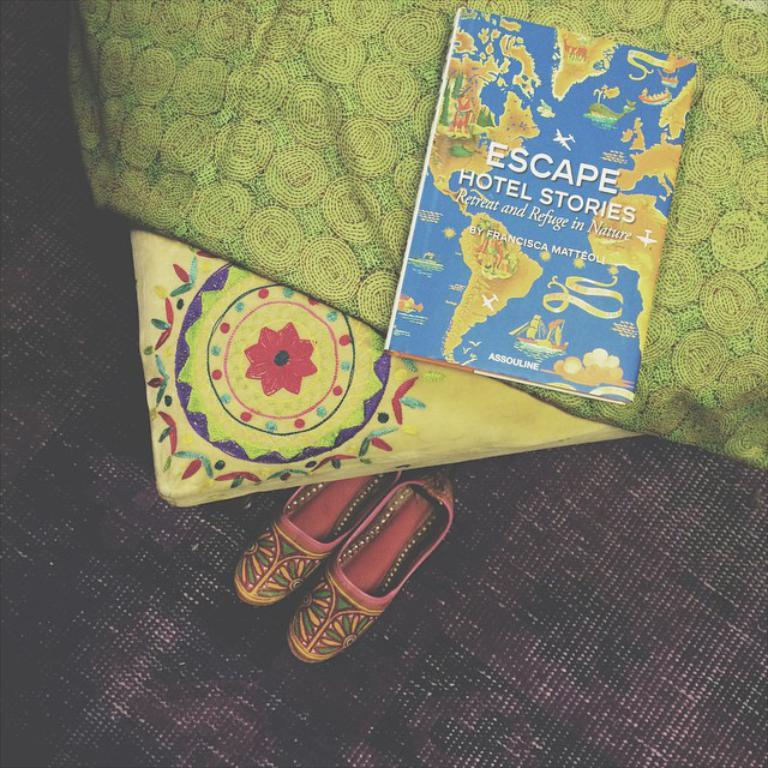Provide a one-sentence caption for the provided image. a book titled "Escape Hotel Stories" sits on a bed. 